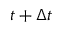Convert formula to latex. <formula><loc_0><loc_0><loc_500><loc_500>t + \Delta t</formula> 